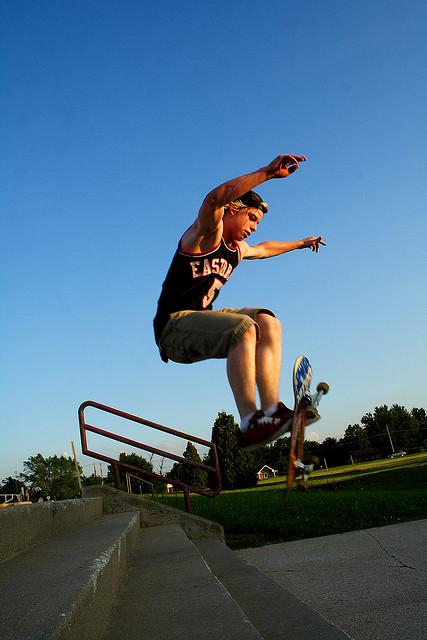What number is on the boy's jersey?
Answer briefly. 5. Is the boy going up or down?
Concise answer only. Down. What piece of clothing is the boy's head on?
Be succinct. Hat. What is on the boys head?
Short answer required. Hat. What is the boy doing?
Write a very short answer. Skateboarding. 